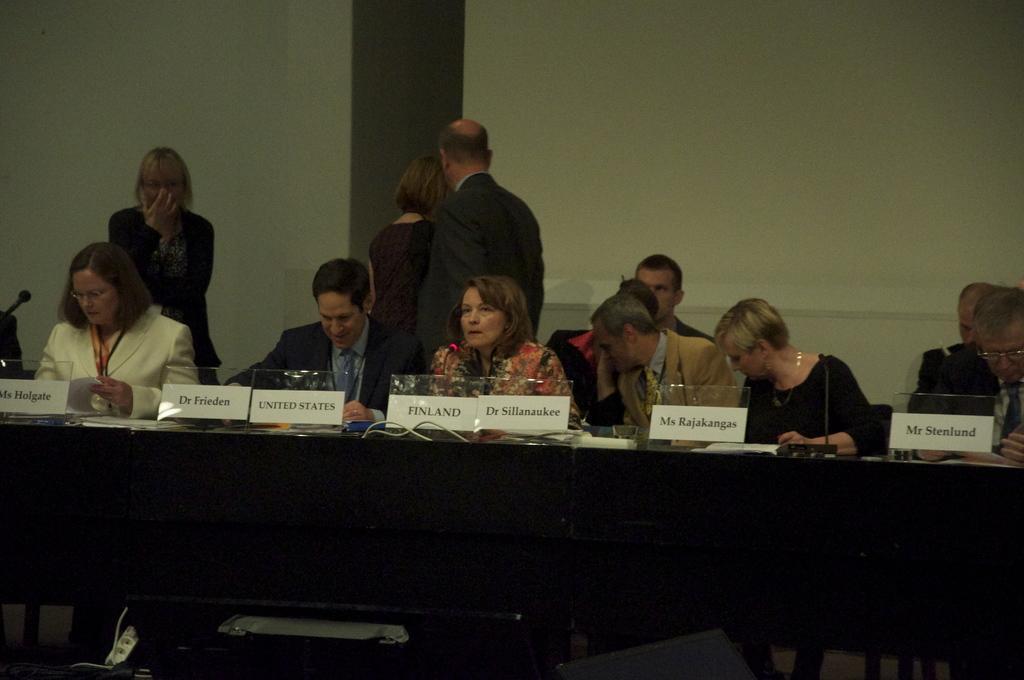How would you summarize this image in a sentence or two? In this image there are persons sitting, there are persons standing, there is a person truncated towards the right of the image, there is a person truncated towards the left of the image, there is a microphone, there is a desk truncated, there are objects on the desk, there are boards, there is text on the board, there is an object truncated towards the bottom of the image, there is a wall truncated. 